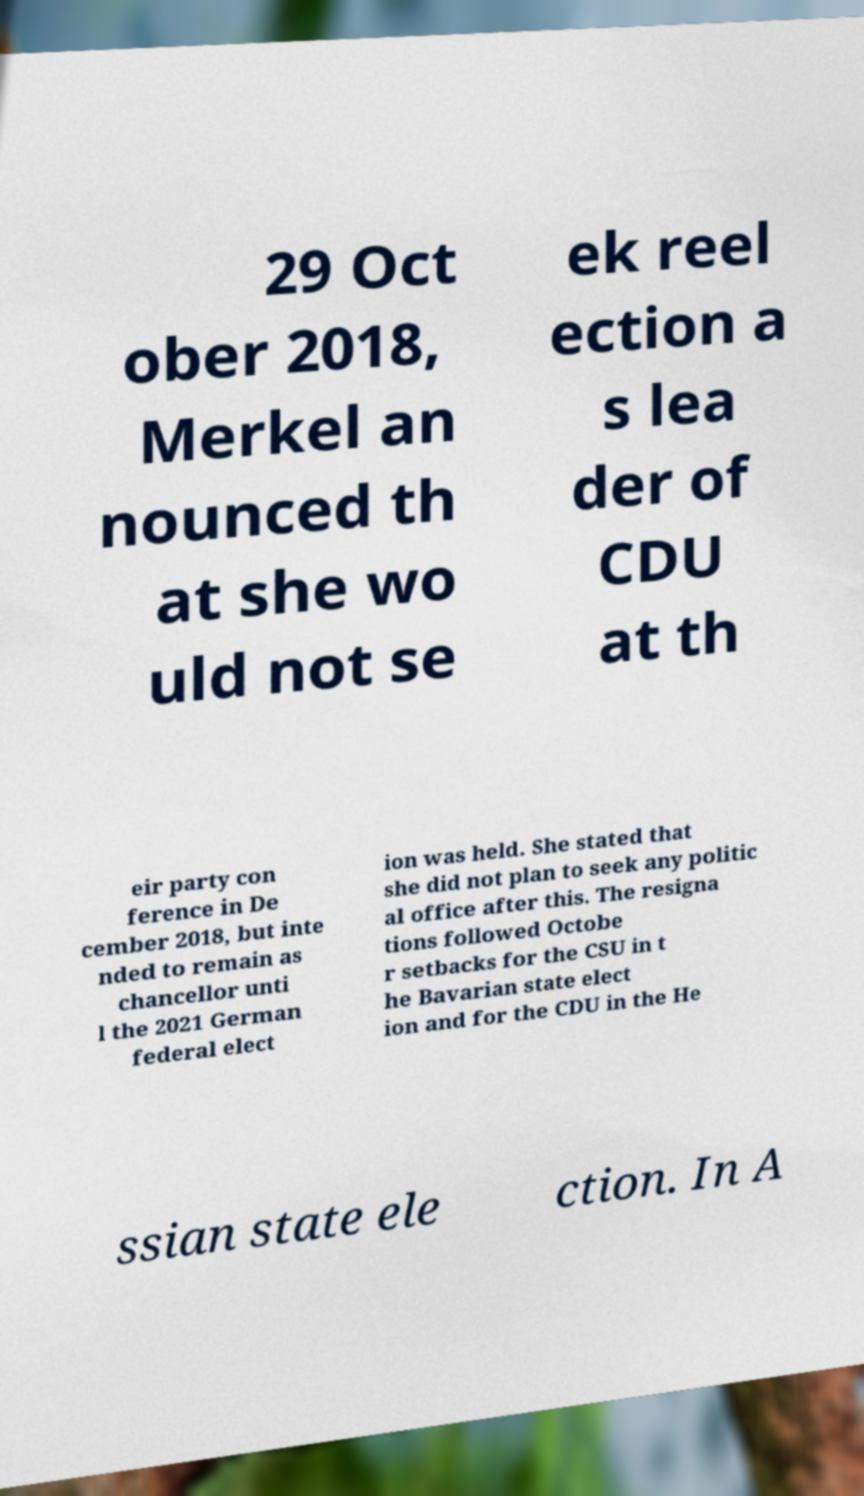Please identify and transcribe the text found in this image. 29 Oct ober 2018, Merkel an nounced th at she wo uld not se ek reel ection a s lea der of CDU at th eir party con ference in De cember 2018, but inte nded to remain as chancellor unti l the 2021 German federal elect ion was held. She stated that she did not plan to seek any politic al office after this. The resigna tions followed Octobe r setbacks for the CSU in t he Bavarian state elect ion and for the CDU in the He ssian state ele ction. In A 